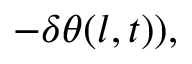<formula> <loc_0><loc_0><loc_500><loc_500>\begin{array} { r l } { - \delta \theta ( l , t ) ) , } \end{array}</formula> 